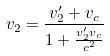<formula> <loc_0><loc_0><loc_500><loc_500>v _ { 2 } = \frac { v _ { 2 } ^ { \prime } + v _ { c } } { 1 + \frac { v _ { 2 } ^ { \prime } v _ { c } } { c ^ { 2 } } }</formula> 